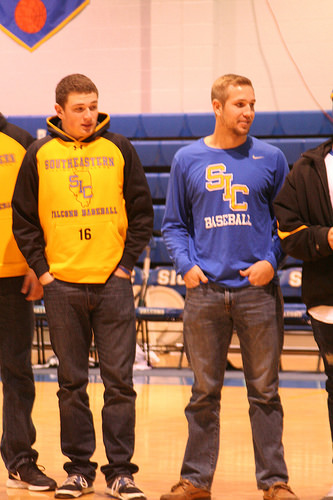<image>
Can you confirm if the sixteen is on the boy? Yes. Looking at the image, I can see the sixteen is positioned on top of the boy, with the boy providing support. Where is the shirt in relation to the pants? Is it above the pants? No. The shirt is not positioned above the pants. The vertical arrangement shows a different relationship. 